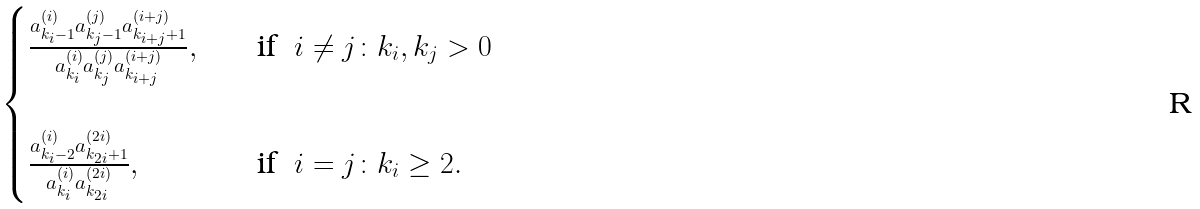Convert formula to latex. <formula><loc_0><loc_0><loc_500><loc_500>\begin{cases} \frac { a _ { k _ { i } - 1 } ^ { ( i ) } a _ { k _ { j } - 1 } ^ { ( j ) } a _ { k _ { i + j } + 1 } ^ { ( i + j ) } } { a _ { k _ { i } } ^ { ( i ) } a _ { k _ { j } } ^ { ( j ) } a _ { k _ { i + j } } ^ { ( i + j ) } } , & \quad \text {if} \ \ i \neq j \colon k _ { i } , k _ { j } > 0 \\ \\ \frac { a _ { k _ { i } - 2 } ^ { ( i ) } a _ { k _ { 2 i } + 1 } ^ { ( 2 i ) } } { a _ { k _ { i } } ^ { ( i ) } a _ { k _ { 2 i } } ^ { ( 2 i ) } } , & \quad \text {if} \ \ i = j \colon k _ { i } \geq 2 . \end{cases}</formula> 